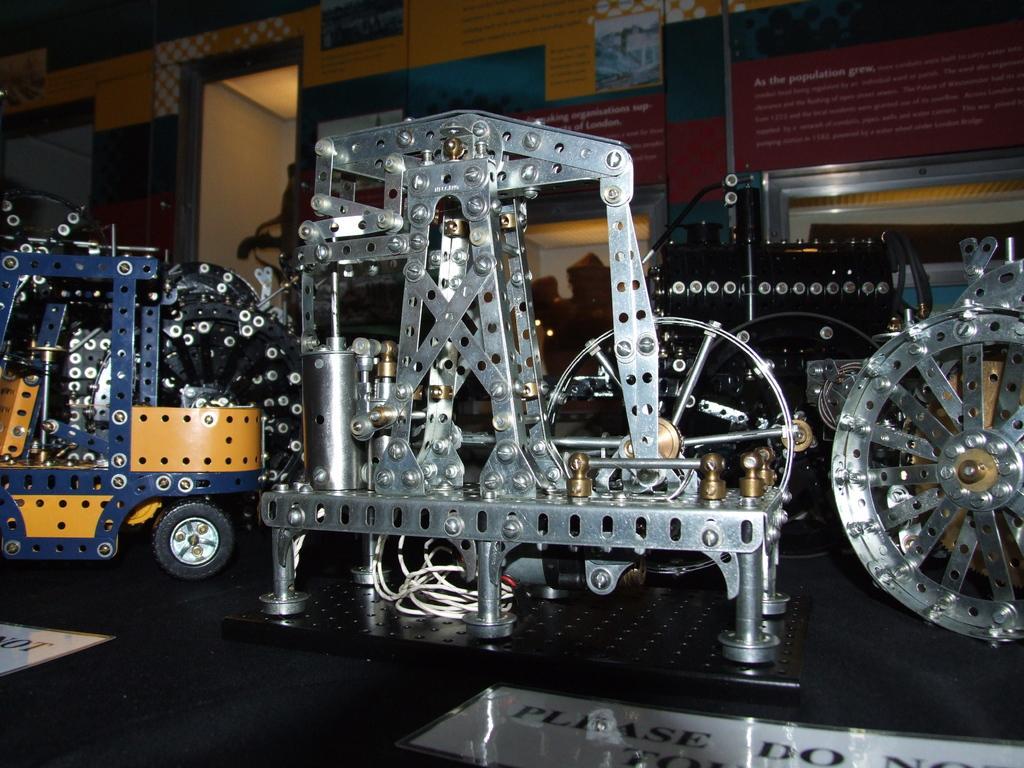Describe this image in one or two sentences. In the image on the black surface there are few models in different shapes. On the black surface there is a white paper with something written on it. In the background there is a wall with posters. 